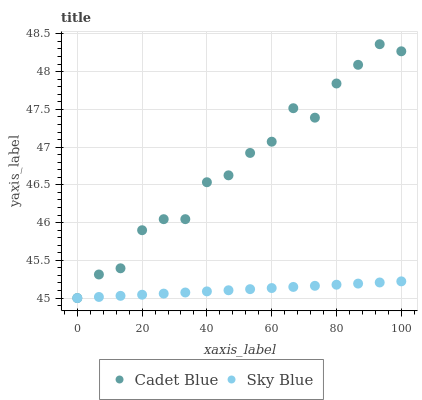Does Sky Blue have the minimum area under the curve?
Answer yes or no. Yes. Does Cadet Blue have the maximum area under the curve?
Answer yes or no. Yes. Does Cadet Blue have the minimum area under the curve?
Answer yes or no. No. Is Sky Blue the smoothest?
Answer yes or no. Yes. Is Cadet Blue the roughest?
Answer yes or no. Yes. Is Cadet Blue the smoothest?
Answer yes or no. No. Does Sky Blue have the lowest value?
Answer yes or no. Yes. Does Cadet Blue have the highest value?
Answer yes or no. Yes. Does Cadet Blue intersect Sky Blue?
Answer yes or no. Yes. Is Cadet Blue less than Sky Blue?
Answer yes or no. No. Is Cadet Blue greater than Sky Blue?
Answer yes or no. No. 